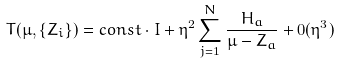Convert formula to latex. <formula><loc_0><loc_0><loc_500><loc_500>T ( \mu , \{ Z _ { i } \} ) = c o n s t \cdot I + \eta ^ { 2 } \sum _ { j = 1 } ^ { N } \frac { H _ { a } } { \mu - Z _ { a } } + 0 ( \eta ^ { 3 } )</formula> 